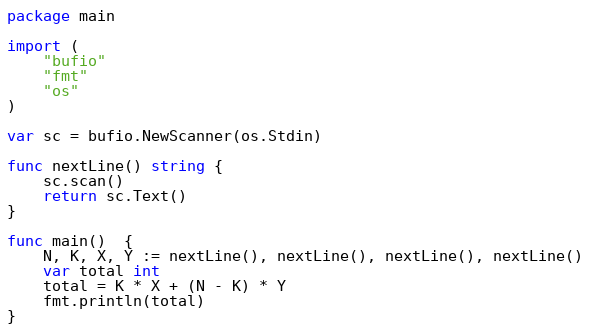Convert code to text. <code><loc_0><loc_0><loc_500><loc_500><_Go_>package main

import (
	"bufio"
	"fmt"
	"os"
)

var sc = bufio.NewScanner(os.Stdin)

func nextLine() string {
	sc.scan()
	return sc.Text()
}

func main()  {
	N, K, X, Y := nextLine(), nextLine(), nextLine(), nextLine()
	var total int
	total = K * X + (N - K) * Y
	fmt.println(total)
}</code> 